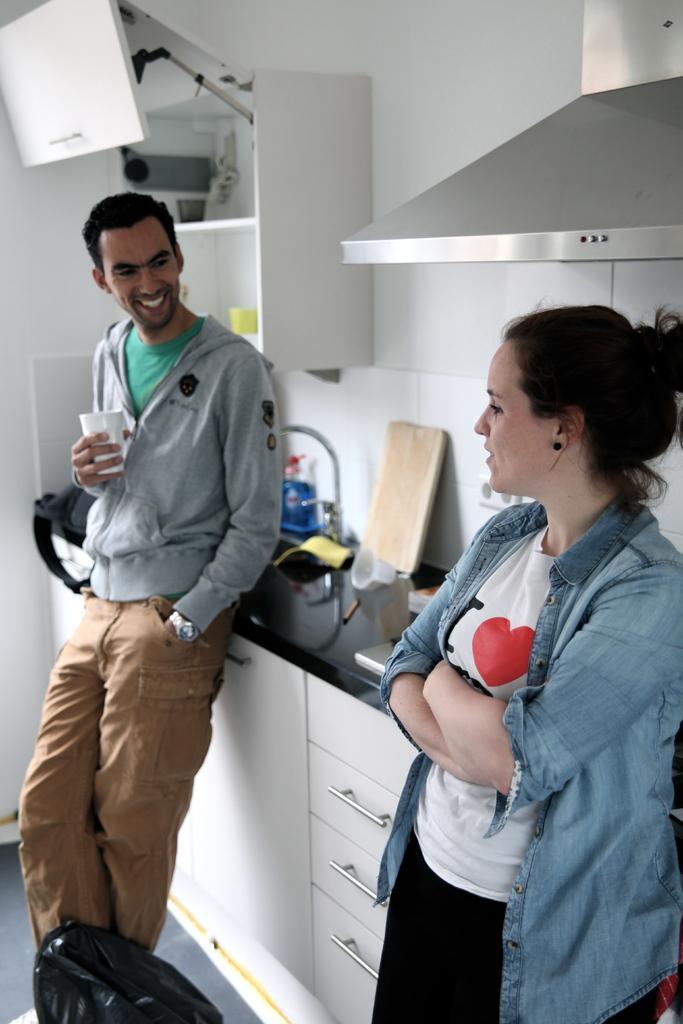In one or two sentences, can you explain what this image depicts? In this image we can see a man and a lady., the man is holding a glass, there is a bag, wooden board, and some other objects on the kitchen slab, there are closets, and a cupboard, there is an exhaust fan, also we can see the wall. 